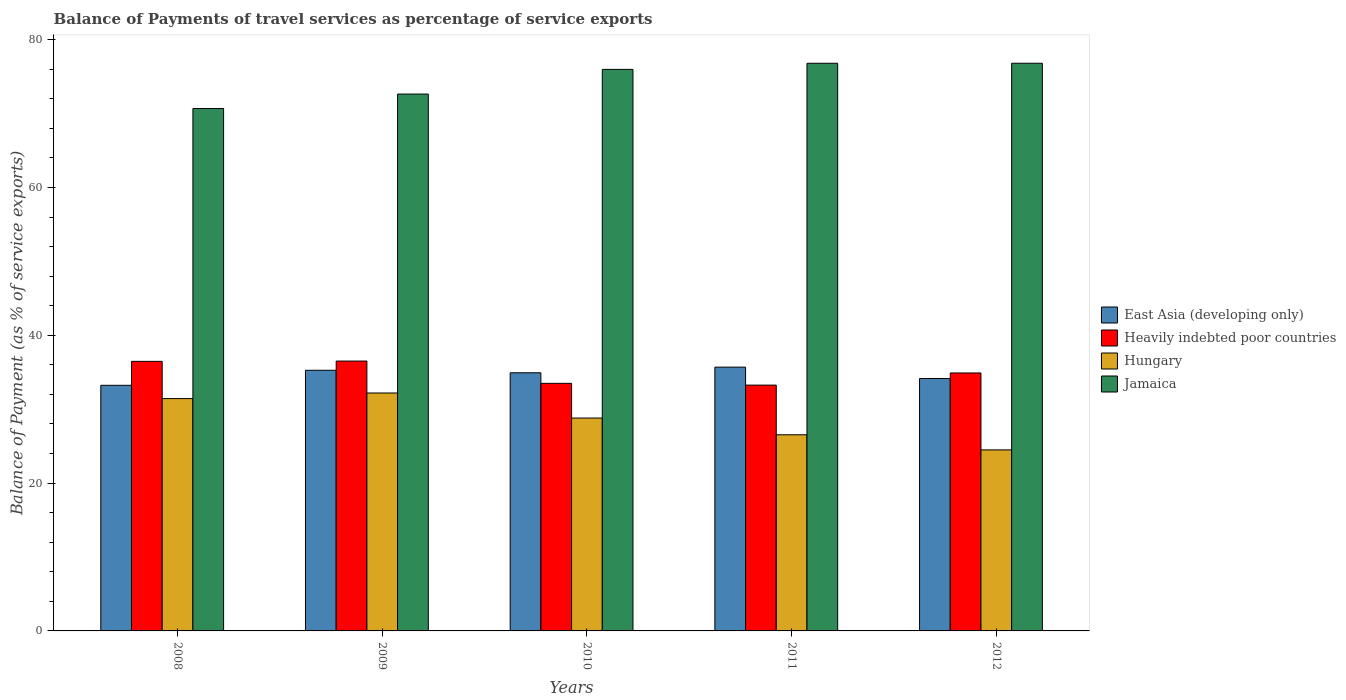How many bars are there on the 5th tick from the left?
Provide a succinct answer. 4. How many bars are there on the 3rd tick from the right?
Offer a very short reply. 4. In how many cases, is the number of bars for a given year not equal to the number of legend labels?
Make the answer very short. 0. What is the balance of payments of travel services in Heavily indebted poor countries in 2010?
Provide a succinct answer. 33.5. Across all years, what is the maximum balance of payments of travel services in East Asia (developing only)?
Provide a short and direct response. 35.69. Across all years, what is the minimum balance of payments of travel services in Hungary?
Give a very brief answer. 24.5. In which year was the balance of payments of travel services in Heavily indebted poor countries maximum?
Keep it short and to the point. 2009. What is the total balance of payments of travel services in Hungary in the graph?
Your response must be concise. 143.47. What is the difference between the balance of payments of travel services in Heavily indebted poor countries in 2009 and that in 2010?
Your answer should be very brief. 3.01. What is the difference between the balance of payments of travel services in East Asia (developing only) in 2009 and the balance of payments of travel services in Jamaica in 2012?
Make the answer very short. -41.54. What is the average balance of payments of travel services in Hungary per year?
Your answer should be very brief. 28.69. In the year 2011, what is the difference between the balance of payments of travel services in Hungary and balance of payments of travel services in Heavily indebted poor countries?
Provide a short and direct response. -6.72. In how many years, is the balance of payments of travel services in Heavily indebted poor countries greater than 44 %?
Provide a short and direct response. 0. What is the ratio of the balance of payments of travel services in Jamaica in 2009 to that in 2011?
Make the answer very short. 0.95. Is the balance of payments of travel services in Heavily indebted poor countries in 2008 less than that in 2011?
Your answer should be very brief. No. Is the difference between the balance of payments of travel services in Hungary in 2011 and 2012 greater than the difference between the balance of payments of travel services in Heavily indebted poor countries in 2011 and 2012?
Make the answer very short. Yes. What is the difference between the highest and the second highest balance of payments of travel services in East Asia (developing only)?
Your answer should be very brief. 0.43. What is the difference between the highest and the lowest balance of payments of travel services in Hungary?
Offer a very short reply. 7.7. In how many years, is the balance of payments of travel services in Hungary greater than the average balance of payments of travel services in Hungary taken over all years?
Keep it short and to the point. 3. Is the sum of the balance of payments of travel services in Heavily indebted poor countries in 2008 and 2012 greater than the maximum balance of payments of travel services in Jamaica across all years?
Make the answer very short. No. What does the 1st bar from the left in 2008 represents?
Your response must be concise. East Asia (developing only). What does the 3rd bar from the right in 2011 represents?
Offer a very short reply. Heavily indebted poor countries. How many years are there in the graph?
Ensure brevity in your answer.  5. Are the values on the major ticks of Y-axis written in scientific E-notation?
Your answer should be very brief. No. Does the graph contain grids?
Provide a succinct answer. No. How are the legend labels stacked?
Ensure brevity in your answer.  Vertical. What is the title of the graph?
Give a very brief answer. Balance of Payments of travel services as percentage of service exports. Does "Solomon Islands" appear as one of the legend labels in the graph?
Your answer should be very brief. No. What is the label or title of the Y-axis?
Provide a short and direct response. Balance of Payment (as % of service exports). What is the Balance of Payment (as % of service exports) of East Asia (developing only) in 2008?
Give a very brief answer. 33.23. What is the Balance of Payment (as % of service exports) in Heavily indebted poor countries in 2008?
Make the answer very short. 36.48. What is the Balance of Payment (as % of service exports) in Hungary in 2008?
Make the answer very short. 31.44. What is the Balance of Payment (as % of service exports) in Jamaica in 2008?
Provide a succinct answer. 70.69. What is the Balance of Payment (as % of service exports) in East Asia (developing only) in 2009?
Provide a succinct answer. 35.27. What is the Balance of Payment (as % of service exports) of Heavily indebted poor countries in 2009?
Your answer should be very brief. 36.51. What is the Balance of Payment (as % of service exports) in Hungary in 2009?
Keep it short and to the point. 32.2. What is the Balance of Payment (as % of service exports) in Jamaica in 2009?
Keep it short and to the point. 72.64. What is the Balance of Payment (as % of service exports) of East Asia (developing only) in 2010?
Give a very brief answer. 34.93. What is the Balance of Payment (as % of service exports) of Heavily indebted poor countries in 2010?
Your answer should be very brief. 33.5. What is the Balance of Payment (as % of service exports) of Hungary in 2010?
Make the answer very short. 28.8. What is the Balance of Payment (as % of service exports) of Jamaica in 2010?
Offer a very short reply. 75.98. What is the Balance of Payment (as % of service exports) of East Asia (developing only) in 2011?
Offer a terse response. 35.69. What is the Balance of Payment (as % of service exports) of Heavily indebted poor countries in 2011?
Keep it short and to the point. 33.26. What is the Balance of Payment (as % of service exports) in Hungary in 2011?
Provide a succinct answer. 26.54. What is the Balance of Payment (as % of service exports) in Jamaica in 2011?
Keep it short and to the point. 76.81. What is the Balance of Payment (as % of service exports) of East Asia (developing only) in 2012?
Provide a succinct answer. 34.16. What is the Balance of Payment (as % of service exports) in Heavily indebted poor countries in 2012?
Your answer should be very brief. 34.91. What is the Balance of Payment (as % of service exports) of Hungary in 2012?
Give a very brief answer. 24.5. What is the Balance of Payment (as % of service exports) of Jamaica in 2012?
Offer a terse response. 76.81. Across all years, what is the maximum Balance of Payment (as % of service exports) in East Asia (developing only)?
Your response must be concise. 35.69. Across all years, what is the maximum Balance of Payment (as % of service exports) of Heavily indebted poor countries?
Your answer should be very brief. 36.51. Across all years, what is the maximum Balance of Payment (as % of service exports) in Hungary?
Your answer should be very brief. 32.2. Across all years, what is the maximum Balance of Payment (as % of service exports) in Jamaica?
Offer a very short reply. 76.81. Across all years, what is the minimum Balance of Payment (as % of service exports) of East Asia (developing only)?
Keep it short and to the point. 33.23. Across all years, what is the minimum Balance of Payment (as % of service exports) of Heavily indebted poor countries?
Your answer should be very brief. 33.26. Across all years, what is the minimum Balance of Payment (as % of service exports) in Hungary?
Your answer should be compact. 24.5. Across all years, what is the minimum Balance of Payment (as % of service exports) in Jamaica?
Ensure brevity in your answer.  70.69. What is the total Balance of Payment (as % of service exports) in East Asia (developing only) in the graph?
Provide a short and direct response. 173.28. What is the total Balance of Payment (as % of service exports) of Heavily indebted poor countries in the graph?
Keep it short and to the point. 174.65. What is the total Balance of Payment (as % of service exports) in Hungary in the graph?
Ensure brevity in your answer.  143.47. What is the total Balance of Payment (as % of service exports) of Jamaica in the graph?
Offer a terse response. 372.93. What is the difference between the Balance of Payment (as % of service exports) of East Asia (developing only) in 2008 and that in 2009?
Your response must be concise. -2.03. What is the difference between the Balance of Payment (as % of service exports) of Heavily indebted poor countries in 2008 and that in 2009?
Your answer should be very brief. -0.04. What is the difference between the Balance of Payment (as % of service exports) of Hungary in 2008 and that in 2009?
Your response must be concise. -0.76. What is the difference between the Balance of Payment (as % of service exports) of Jamaica in 2008 and that in 2009?
Offer a terse response. -1.96. What is the difference between the Balance of Payment (as % of service exports) in East Asia (developing only) in 2008 and that in 2010?
Ensure brevity in your answer.  -1.7. What is the difference between the Balance of Payment (as % of service exports) of Heavily indebted poor countries in 2008 and that in 2010?
Provide a succinct answer. 2.98. What is the difference between the Balance of Payment (as % of service exports) of Hungary in 2008 and that in 2010?
Your answer should be compact. 2.63. What is the difference between the Balance of Payment (as % of service exports) in Jamaica in 2008 and that in 2010?
Provide a succinct answer. -5.29. What is the difference between the Balance of Payment (as % of service exports) in East Asia (developing only) in 2008 and that in 2011?
Your response must be concise. -2.46. What is the difference between the Balance of Payment (as % of service exports) of Heavily indebted poor countries in 2008 and that in 2011?
Offer a very short reply. 3.22. What is the difference between the Balance of Payment (as % of service exports) of Hungary in 2008 and that in 2011?
Your response must be concise. 4.9. What is the difference between the Balance of Payment (as % of service exports) of Jamaica in 2008 and that in 2011?
Offer a very short reply. -6.12. What is the difference between the Balance of Payment (as % of service exports) in East Asia (developing only) in 2008 and that in 2012?
Offer a terse response. -0.92. What is the difference between the Balance of Payment (as % of service exports) in Heavily indebted poor countries in 2008 and that in 2012?
Your response must be concise. 1.57. What is the difference between the Balance of Payment (as % of service exports) of Hungary in 2008 and that in 2012?
Provide a succinct answer. 6.94. What is the difference between the Balance of Payment (as % of service exports) in Jamaica in 2008 and that in 2012?
Offer a terse response. -6.12. What is the difference between the Balance of Payment (as % of service exports) of East Asia (developing only) in 2009 and that in 2010?
Offer a terse response. 0.34. What is the difference between the Balance of Payment (as % of service exports) of Heavily indebted poor countries in 2009 and that in 2010?
Provide a succinct answer. 3.01. What is the difference between the Balance of Payment (as % of service exports) of Hungary in 2009 and that in 2010?
Offer a terse response. 3.39. What is the difference between the Balance of Payment (as % of service exports) of Jamaica in 2009 and that in 2010?
Offer a terse response. -3.34. What is the difference between the Balance of Payment (as % of service exports) in East Asia (developing only) in 2009 and that in 2011?
Give a very brief answer. -0.43. What is the difference between the Balance of Payment (as % of service exports) of Heavily indebted poor countries in 2009 and that in 2011?
Keep it short and to the point. 3.26. What is the difference between the Balance of Payment (as % of service exports) in Hungary in 2009 and that in 2011?
Offer a very short reply. 5.65. What is the difference between the Balance of Payment (as % of service exports) of Jamaica in 2009 and that in 2011?
Your answer should be compact. -4.16. What is the difference between the Balance of Payment (as % of service exports) in East Asia (developing only) in 2009 and that in 2012?
Your response must be concise. 1.11. What is the difference between the Balance of Payment (as % of service exports) of Heavily indebted poor countries in 2009 and that in 2012?
Keep it short and to the point. 1.61. What is the difference between the Balance of Payment (as % of service exports) in Jamaica in 2009 and that in 2012?
Your response must be concise. -4.17. What is the difference between the Balance of Payment (as % of service exports) of East Asia (developing only) in 2010 and that in 2011?
Your response must be concise. -0.76. What is the difference between the Balance of Payment (as % of service exports) in Heavily indebted poor countries in 2010 and that in 2011?
Ensure brevity in your answer.  0.24. What is the difference between the Balance of Payment (as % of service exports) in Hungary in 2010 and that in 2011?
Provide a short and direct response. 2.26. What is the difference between the Balance of Payment (as % of service exports) in Jamaica in 2010 and that in 2011?
Ensure brevity in your answer.  -0.83. What is the difference between the Balance of Payment (as % of service exports) in East Asia (developing only) in 2010 and that in 2012?
Offer a terse response. 0.77. What is the difference between the Balance of Payment (as % of service exports) in Heavily indebted poor countries in 2010 and that in 2012?
Make the answer very short. -1.41. What is the difference between the Balance of Payment (as % of service exports) of Hungary in 2010 and that in 2012?
Offer a very short reply. 4.31. What is the difference between the Balance of Payment (as % of service exports) of Jamaica in 2010 and that in 2012?
Your answer should be compact. -0.83. What is the difference between the Balance of Payment (as % of service exports) of East Asia (developing only) in 2011 and that in 2012?
Your answer should be very brief. 1.54. What is the difference between the Balance of Payment (as % of service exports) in Heavily indebted poor countries in 2011 and that in 2012?
Keep it short and to the point. -1.65. What is the difference between the Balance of Payment (as % of service exports) of Hungary in 2011 and that in 2012?
Your response must be concise. 2.05. What is the difference between the Balance of Payment (as % of service exports) in Jamaica in 2011 and that in 2012?
Provide a succinct answer. -0. What is the difference between the Balance of Payment (as % of service exports) in East Asia (developing only) in 2008 and the Balance of Payment (as % of service exports) in Heavily indebted poor countries in 2009?
Your response must be concise. -3.28. What is the difference between the Balance of Payment (as % of service exports) of East Asia (developing only) in 2008 and the Balance of Payment (as % of service exports) of Hungary in 2009?
Your answer should be very brief. 1.04. What is the difference between the Balance of Payment (as % of service exports) of East Asia (developing only) in 2008 and the Balance of Payment (as % of service exports) of Jamaica in 2009?
Make the answer very short. -39.41. What is the difference between the Balance of Payment (as % of service exports) in Heavily indebted poor countries in 2008 and the Balance of Payment (as % of service exports) in Hungary in 2009?
Give a very brief answer. 4.28. What is the difference between the Balance of Payment (as % of service exports) of Heavily indebted poor countries in 2008 and the Balance of Payment (as % of service exports) of Jamaica in 2009?
Offer a terse response. -36.17. What is the difference between the Balance of Payment (as % of service exports) in Hungary in 2008 and the Balance of Payment (as % of service exports) in Jamaica in 2009?
Give a very brief answer. -41.21. What is the difference between the Balance of Payment (as % of service exports) in East Asia (developing only) in 2008 and the Balance of Payment (as % of service exports) in Heavily indebted poor countries in 2010?
Provide a succinct answer. -0.27. What is the difference between the Balance of Payment (as % of service exports) in East Asia (developing only) in 2008 and the Balance of Payment (as % of service exports) in Hungary in 2010?
Make the answer very short. 4.43. What is the difference between the Balance of Payment (as % of service exports) in East Asia (developing only) in 2008 and the Balance of Payment (as % of service exports) in Jamaica in 2010?
Give a very brief answer. -42.74. What is the difference between the Balance of Payment (as % of service exports) in Heavily indebted poor countries in 2008 and the Balance of Payment (as % of service exports) in Hungary in 2010?
Give a very brief answer. 7.67. What is the difference between the Balance of Payment (as % of service exports) in Heavily indebted poor countries in 2008 and the Balance of Payment (as % of service exports) in Jamaica in 2010?
Provide a short and direct response. -39.5. What is the difference between the Balance of Payment (as % of service exports) of Hungary in 2008 and the Balance of Payment (as % of service exports) of Jamaica in 2010?
Give a very brief answer. -44.54. What is the difference between the Balance of Payment (as % of service exports) of East Asia (developing only) in 2008 and the Balance of Payment (as % of service exports) of Heavily indebted poor countries in 2011?
Make the answer very short. -0.03. What is the difference between the Balance of Payment (as % of service exports) of East Asia (developing only) in 2008 and the Balance of Payment (as % of service exports) of Hungary in 2011?
Your answer should be compact. 6.69. What is the difference between the Balance of Payment (as % of service exports) in East Asia (developing only) in 2008 and the Balance of Payment (as % of service exports) in Jamaica in 2011?
Your answer should be compact. -43.57. What is the difference between the Balance of Payment (as % of service exports) of Heavily indebted poor countries in 2008 and the Balance of Payment (as % of service exports) of Hungary in 2011?
Make the answer very short. 9.94. What is the difference between the Balance of Payment (as % of service exports) of Heavily indebted poor countries in 2008 and the Balance of Payment (as % of service exports) of Jamaica in 2011?
Offer a terse response. -40.33. What is the difference between the Balance of Payment (as % of service exports) in Hungary in 2008 and the Balance of Payment (as % of service exports) in Jamaica in 2011?
Your answer should be compact. -45.37. What is the difference between the Balance of Payment (as % of service exports) of East Asia (developing only) in 2008 and the Balance of Payment (as % of service exports) of Heavily indebted poor countries in 2012?
Give a very brief answer. -1.67. What is the difference between the Balance of Payment (as % of service exports) in East Asia (developing only) in 2008 and the Balance of Payment (as % of service exports) in Hungary in 2012?
Your answer should be compact. 8.74. What is the difference between the Balance of Payment (as % of service exports) in East Asia (developing only) in 2008 and the Balance of Payment (as % of service exports) in Jamaica in 2012?
Your answer should be very brief. -43.58. What is the difference between the Balance of Payment (as % of service exports) in Heavily indebted poor countries in 2008 and the Balance of Payment (as % of service exports) in Hungary in 2012?
Your answer should be very brief. 11.98. What is the difference between the Balance of Payment (as % of service exports) of Heavily indebted poor countries in 2008 and the Balance of Payment (as % of service exports) of Jamaica in 2012?
Make the answer very short. -40.34. What is the difference between the Balance of Payment (as % of service exports) in Hungary in 2008 and the Balance of Payment (as % of service exports) in Jamaica in 2012?
Your answer should be compact. -45.37. What is the difference between the Balance of Payment (as % of service exports) of East Asia (developing only) in 2009 and the Balance of Payment (as % of service exports) of Heavily indebted poor countries in 2010?
Your answer should be compact. 1.77. What is the difference between the Balance of Payment (as % of service exports) of East Asia (developing only) in 2009 and the Balance of Payment (as % of service exports) of Hungary in 2010?
Your answer should be compact. 6.46. What is the difference between the Balance of Payment (as % of service exports) in East Asia (developing only) in 2009 and the Balance of Payment (as % of service exports) in Jamaica in 2010?
Give a very brief answer. -40.71. What is the difference between the Balance of Payment (as % of service exports) of Heavily indebted poor countries in 2009 and the Balance of Payment (as % of service exports) of Hungary in 2010?
Offer a very short reply. 7.71. What is the difference between the Balance of Payment (as % of service exports) of Heavily indebted poor countries in 2009 and the Balance of Payment (as % of service exports) of Jamaica in 2010?
Provide a succinct answer. -39.46. What is the difference between the Balance of Payment (as % of service exports) of Hungary in 2009 and the Balance of Payment (as % of service exports) of Jamaica in 2010?
Offer a terse response. -43.78. What is the difference between the Balance of Payment (as % of service exports) in East Asia (developing only) in 2009 and the Balance of Payment (as % of service exports) in Heavily indebted poor countries in 2011?
Provide a succinct answer. 2.01. What is the difference between the Balance of Payment (as % of service exports) of East Asia (developing only) in 2009 and the Balance of Payment (as % of service exports) of Hungary in 2011?
Your response must be concise. 8.73. What is the difference between the Balance of Payment (as % of service exports) of East Asia (developing only) in 2009 and the Balance of Payment (as % of service exports) of Jamaica in 2011?
Give a very brief answer. -41.54. What is the difference between the Balance of Payment (as % of service exports) in Heavily indebted poor countries in 2009 and the Balance of Payment (as % of service exports) in Hungary in 2011?
Keep it short and to the point. 9.97. What is the difference between the Balance of Payment (as % of service exports) of Heavily indebted poor countries in 2009 and the Balance of Payment (as % of service exports) of Jamaica in 2011?
Make the answer very short. -40.29. What is the difference between the Balance of Payment (as % of service exports) of Hungary in 2009 and the Balance of Payment (as % of service exports) of Jamaica in 2011?
Ensure brevity in your answer.  -44.61. What is the difference between the Balance of Payment (as % of service exports) of East Asia (developing only) in 2009 and the Balance of Payment (as % of service exports) of Heavily indebted poor countries in 2012?
Your answer should be compact. 0.36. What is the difference between the Balance of Payment (as % of service exports) in East Asia (developing only) in 2009 and the Balance of Payment (as % of service exports) in Hungary in 2012?
Your answer should be very brief. 10.77. What is the difference between the Balance of Payment (as % of service exports) of East Asia (developing only) in 2009 and the Balance of Payment (as % of service exports) of Jamaica in 2012?
Ensure brevity in your answer.  -41.54. What is the difference between the Balance of Payment (as % of service exports) in Heavily indebted poor countries in 2009 and the Balance of Payment (as % of service exports) in Hungary in 2012?
Your answer should be very brief. 12.02. What is the difference between the Balance of Payment (as % of service exports) of Heavily indebted poor countries in 2009 and the Balance of Payment (as % of service exports) of Jamaica in 2012?
Your response must be concise. -40.3. What is the difference between the Balance of Payment (as % of service exports) in Hungary in 2009 and the Balance of Payment (as % of service exports) in Jamaica in 2012?
Your answer should be compact. -44.62. What is the difference between the Balance of Payment (as % of service exports) in East Asia (developing only) in 2010 and the Balance of Payment (as % of service exports) in Heavily indebted poor countries in 2011?
Provide a short and direct response. 1.67. What is the difference between the Balance of Payment (as % of service exports) of East Asia (developing only) in 2010 and the Balance of Payment (as % of service exports) of Hungary in 2011?
Make the answer very short. 8.39. What is the difference between the Balance of Payment (as % of service exports) in East Asia (developing only) in 2010 and the Balance of Payment (as % of service exports) in Jamaica in 2011?
Offer a very short reply. -41.88. What is the difference between the Balance of Payment (as % of service exports) of Heavily indebted poor countries in 2010 and the Balance of Payment (as % of service exports) of Hungary in 2011?
Offer a terse response. 6.96. What is the difference between the Balance of Payment (as % of service exports) in Heavily indebted poor countries in 2010 and the Balance of Payment (as % of service exports) in Jamaica in 2011?
Provide a succinct answer. -43.31. What is the difference between the Balance of Payment (as % of service exports) in Hungary in 2010 and the Balance of Payment (as % of service exports) in Jamaica in 2011?
Your answer should be compact. -48. What is the difference between the Balance of Payment (as % of service exports) of East Asia (developing only) in 2010 and the Balance of Payment (as % of service exports) of Heavily indebted poor countries in 2012?
Your answer should be very brief. 0.03. What is the difference between the Balance of Payment (as % of service exports) of East Asia (developing only) in 2010 and the Balance of Payment (as % of service exports) of Hungary in 2012?
Offer a terse response. 10.44. What is the difference between the Balance of Payment (as % of service exports) in East Asia (developing only) in 2010 and the Balance of Payment (as % of service exports) in Jamaica in 2012?
Provide a succinct answer. -41.88. What is the difference between the Balance of Payment (as % of service exports) of Heavily indebted poor countries in 2010 and the Balance of Payment (as % of service exports) of Hungary in 2012?
Make the answer very short. 9. What is the difference between the Balance of Payment (as % of service exports) in Heavily indebted poor countries in 2010 and the Balance of Payment (as % of service exports) in Jamaica in 2012?
Keep it short and to the point. -43.31. What is the difference between the Balance of Payment (as % of service exports) in Hungary in 2010 and the Balance of Payment (as % of service exports) in Jamaica in 2012?
Give a very brief answer. -48.01. What is the difference between the Balance of Payment (as % of service exports) of East Asia (developing only) in 2011 and the Balance of Payment (as % of service exports) of Heavily indebted poor countries in 2012?
Provide a short and direct response. 0.79. What is the difference between the Balance of Payment (as % of service exports) in East Asia (developing only) in 2011 and the Balance of Payment (as % of service exports) in Hungary in 2012?
Provide a succinct answer. 11.2. What is the difference between the Balance of Payment (as % of service exports) of East Asia (developing only) in 2011 and the Balance of Payment (as % of service exports) of Jamaica in 2012?
Your answer should be compact. -41.12. What is the difference between the Balance of Payment (as % of service exports) of Heavily indebted poor countries in 2011 and the Balance of Payment (as % of service exports) of Hungary in 2012?
Your response must be concise. 8.76. What is the difference between the Balance of Payment (as % of service exports) of Heavily indebted poor countries in 2011 and the Balance of Payment (as % of service exports) of Jamaica in 2012?
Offer a very short reply. -43.55. What is the difference between the Balance of Payment (as % of service exports) of Hungary in 2011 and the Balance of Payment (as % of service exports) of Jamaica in 2012?
Offer a very short reply. -50.27. What is the average Balance of Payment (as % of service exports) in East Asia (developing only) per year?
Provide a short and direct response. 34.66. What is the average Balance of Payment (as % of service exports) of Heavily indebted poor countries per year?
Provide a short and direct response. 34.93. What is the average Balance of Payment (as % of service exports) of Hungary per year?
Give a very brief answer. 28.69. What is the average Balance of Payment (as % of service exports) in Jamaica per year?
Your response must be concise. 74.59. In the year 2008, what is the difference between the Balance of Payment (as % of service exports) of East Asia (developing only) and Balance of Payment (as % of service exports) of Heavily indebted poor countries?
Offer a very short reply. -3.24. In the year 2008, what is the difference between the Balance of Payment (as % of service exports) of East Asia (developing only) and Balance of Payment (as % of service exports) of Hungary?
Your answer should be compact. 1.8. In the year 2008, what is the difference between the Balance of Payment (as % of service exports) in East Asia (developing only) and Balance of Payment (as % of service exports) in Jamaica?
Ensure brevity in your answer.  -37.45. In the year 2008, what is the difference between the Balance of Payment (as % of service exports) of Heavily indebted poor countries and Balance of Payment (as % of service exports) of Hungary?
Your answer should be very brief. 5.04. In the year 2008, what is the difference between the Balance of Payment (as % of service exports) in Heavily indebted poor countries and Balance of Payment (as % of service exports) in Jamaica?
Provide a short and direct response. -34.21. In the year 2008, what is the difference between the Balance of Payment (as % of service exports) of Hungary and Balance of Payment (as % of service exports) of Jamaica?
Offer a terse response. -39.25. In the year 2009, what is the difference between the Balance of Payment (as % of service exports) of East Asia (developing only) and Balance of Payment (as % of service exports) of Heavily indebted poor countries?
Make the answer very short. -1.25. In the year 2009, what is the difference between the Balance of Payment (as % of service exports) in East Asia (developing only) and Balance of Payment (as % of service exports) in Hungary?
Offer a terse response. 3.07. In the year 2009, what is the difference between the Balance of Payment (as % of service exports) in East Asia (developing only) and Balance of Payment (as % of service exports) in Jamaica?
Provide a short and direct response. -37.38. In the year 2009, what is the difference between the Balance of Payment (as % of service exports) in Heavily indebted poor countries and Balance of Payment (as % of service exports) in Hungary?
Ensure brevity in your answer.  4.32. In the year 2009, what is the difference between the Balance of Payment (as % of service exports) in Heavily indebted poor countries and Balance of Payment (as % of service exports) in Jamaica?
Your answer should be very brief. -36.13. In the year 2009, what is the difference between the Balance of Payment (as % of service exports) in Hungary and Balance of Payment (as % of service exports) in Jamaica?
Offer a very short reply. -40.45. In the year 2010, what is the difference between the Balance of Payment (as % of service exports) in East Asia (developing only) and Balance of Payment (as % of service exports) in Heavily indebted poor countries?
Make the answer very short. 1.43. In the year 2010, what is the difference between the Balance of Payment (as % of service exports) of East Asia (developing only) and Balance of Payment (as % of service exports) of Hungary?
Offer a very short reply. 6.13. In the year 2010, what is the difference between the Balance of Payment (as % of service exports) in East Asia (developing only) and Balance of Payment (as % of service exports) in Jamaica?
Your response must be concise. -41.05. In the year 2010, what is the difference between the Balance of Payment (as % of service exports) in Heavily indebted poor countries and Balance of Payment (as % of service exports) in Hungary?
Make the answer very short. 4.7. In the year 2010, what is the difference between the Balance of Payment (as % of service exports) of Heavily indebted poor countries and Balance of Payment (as % of service exports) of Jamaica?
Make the answer very short. -42.48. In the year 2010, what is the difference between the Balance of Payment (as % of service exports) in Hungary and Balance of Payment (as % of service exports) in Jamaica?
Keep it short and to the point. -47.17. In the year 2011, what is the difference between the Balance of Payment (as % of service exports) of East Asia (developing only) and Balance of Payment (as % of service exports) of Heavily indebted poor countries?
Give a very brief answer. 2.43. In the year 2011, what is the difference between the Balance of Payment (as % of service exports) of East Asia (developing only) and Balance of Payment (as % of service exports) of Hungary?
Make the answer very short. 9.15. In the year 2011, what is the difference between the Balance of Payment (as % of service exports) of East Asia (developing only) and Balance of Payment (as % of service exports) of Jamaica?
Provide a short and direct response. -41.11. In the year 2011, what is the difference between the Balance of Payment (as % of service exports) in Heavily indebted poor countries and Balance of Payment (as % of service exports) in Hungary?
Offer a very short reply. 6.72. In the year 2011, what is the difference between the Balance of Payment (as % of service exports) of Heavily indebted poor countries and Balance of Payment (as % of service exports) of Jamaica?
Give a very brief answer. -43.55. In the year 2011, what is the difference between the Balance of Payment (as % of service exports) of Hungary and Balance of Payment (as % of service exports) of Jamaica?
Give a very brief answer. -50.27. In the year 2012, what is the difference between the Balance of Payment (as % of service exports) in East Asia (developing only) and Balance of Payment (as % of service exports) in Heavily indebted poor countries?
Offer a terse response. -0.75. In the year 2012, what is the difference between the Balance of Payment (as % of service exports) of East Asia (developing only) and Balance of Payment (as % of service exports) of Hungary?
Keep it short and to the point. 9.66. In the year 2012, what is the difference between the Balance of Payment (as % of service exports) in East Asia (developing only) and Balance of Payment (as % of service exports) in Jamaica?
Ensure brevity in your answer.  -42.65. In the year 2012, what is the difference between the Balance of Payment (as % of service exports) in Heavily indebted poor countries and Balance of Payment (as % of service exports) in Hungary?
Offer a very short reply. 10.41. In the year 2012, what is the difference between the Balance of Payment (as % of service exports) of Heavily indebted poor countries and Balance of Payment (as % of service exports) of Jamaica?
Your response must be concise. -41.91. In the year 2012, what is the difference between the Balance of Payment (as % of service exports) of Hungary and Balance of Payment (as % of service exports) of Jamaica?
Make the answer very short. -52.32. What is the ratio of the Balance of Payment (as % of service exports) in East Asia (developing only) in 2008 to that in 2009?
Keep it short and to the point. 0.94. What is the ratio of the Balance of Payment (as % of service exports) of Hungary in 2008 to that in 2009?
Your answer should be compact. 0.98. What is the ratio of the Balance of Payment (as % of service exports) of Jamaica in 2008 to that in 2009?
Your response must be concise. 0.97. What is the ratio of the Balance of Payment (as % of service exports) in East Asia (developing only) in 2008 to that in 2010?
Your answer should be compact. 0.95. What is the ratio of the Balance of Payment (as % of service exports) of Heavily indebted poor countries in 2008 to that in 2010?
Make the answer very short. 1.09. What is the ratio of the Balance of Payment (as % of service exports) of Hungary in 2008 to that in 2010?
Your response must be concise. 1.09. What is the ratio of the Balance of Payment (as % of service exports) of Jamaica in 2008 to that in 2010?
Give a very brief answer. 0.93. What is the ratio of the Balance of Payment (as % of service exports) of East Asia (developing only) in 2008 to that in 2011?
Keep it short and to the point. 0.93. What is the ratio of the Balance of Payment (as % of service exports) of Heavily indebted poor countries in 2008 to that in 2011?
Your response must be concise. 1.1. What is the ratio of the Balance of Payment (as % of service exports) of Hungary in 2008 to that in 2011?
Keep it short and to the point. 1.18. What is the ratio of the Balance of Payment (as % of service exports) of Jamaica in 2008 to that in 2011?
Keep it short and to the point. 0.92. What is the ratio of the Balance of Payment (as % of service exports) in Heavily indebted poor countries in 2008 to that in 2012?
Your response must be concise. 1.04. What is the ratio of the Balance of Payment (as % of service exports) of Hungary in 2008 to that in 2012?
Your response must be concise. 1.28. What is the ratio of the Balance of Payment (as % of service exports) in Jamaica in 2008 to that in 2012?
Provide a succinct answer. 0.92. What is the ratio of the Balance of Payment (as % of service exports) of East Asia (developing only) in 2009 to that in 2010?
Ensure brevity in your answer.  1.01. What is the ratio of the Balance of Payment (as % of service exports) of Heavily indebted poor countries in 2009 to that in 2010?
Offer a terse response. 1.09. What is the ratio of the Balance of Payment (as % of service exports) of Hungary in 2009 to that in 2010?
Offer a very short reply. 1.12. What is the ratio of the Balance of Payment (as % of service exports) of Jamaica in 2009 to that in 2010?
Provide a succinct answer. 0.96. What is the ratio of the Balance of Payment (as % of service exports) in East Asia (developing only) in 2009 to that in 2011?
Offer a terse response. 0.99. What is the ratio of the Balance of Payment (as % of service exports) of Heavily indebted poor countries in 2009 to that in 2011?
Your answer should be compact. 1.1. What is the ratio of the Balance of Payment (as % of service exports) of Hungary in 2009 to that in 2011?
Offer a terse response. 1.21. What is the ratio of the Balance of Payment (as % of service exports) in Jamaica in 2009 to that in 2011?
Make the answer very short. 0.95. What is the ratio of the Balance of Payment (as % of service exports) in East Asia (developing only) in 2009 to that in 2012?
Your answer should be very brief. 1.03. What is the ratio of the Balance of Payment (as % of service exports) of Heavily indebted poor countries in 2009 to that in 2012?
Provide a short and direct response. 1.05. What is the ratio of the Balance of Payment (as % of service exports) in Hungary in 2009 to that in 2012?
Make the answer very short. 1.31. What is the ratio of the Balance of Payment (as % of service exports) in Jamaica in 2009 to that in 2012?
Keep it short and to the point. 0.95. What is the ratio of the Balance of Payment (as % of service exports) of East Asia (developing only) in 2010 to that in 2011?
Ensure brevity in your answer.  0.98. What is the ratio of the Balance of Payment (as % of service exports) of Hungary in 2010 to that in 2011?
Keep it short and to the point. 1.09. What is the ratio of the Balance of Payment (as % of service exports) in Jamaica in 2010 to that in 2011?
Make the answer very short. 0.99. What is the ratio of the Balance of Payment (as % of service exports) in East Asia (developing only) in 2010 to that in 2012?
Your response must be concise. 1.02. What is the ratio of the Balance of Payment (as % of service exports) of Heavily indebted poor countries in 2010 to that in 2012?
Your answer should be compact. 0.96. What is the ratio of the Balance of Payment (as % of service exports) in Hungary in 2010 to that in 2012?
Your answer should be very brief. 1.18. What is the ratio of the Balance of Payment (as % of service exports) in East Asia (developing only) in 2011 to that in 2012?
Keep it short and to the point. 1.04. What is the ratio of the Balance of Payment (as % of service exports) of Heavily indebted poor countries in 2011 to that in 2012?
Your answer should be compact. 0.95. What is the ratio of the Balance of Payment (as % of service exports) of Hungary in 2011 to that in 2012?
Ensure brevity in your answer.  1.08. What is the difference between the highest and the second highest Balance of Payment (as % of service exports) in East Asia (developing only)?
Your response must be concise. 0.43. What is the difference between the highest and the second highest Balance of Payment (as % of service exports) in Heavily indebted poor countries?
Keep it short and to the point. 0.04. What is the difference between the highest and the second highest Balance of Payment (as % of service exports) in Hungary?
Offer a terse response. 0.76. What is the difference between the highest and the second highest Balance of Payment (as % of service exports) in Jamaica?
Your answer should be compact. 0. What is the difference between the highest and the lowest Balance of Payment (as % of service exports) of East Asia (developing only)?
Make the answer very short. 2.46. What is the difference between the highest and the lowest Balance of Payment (as % of service exports) in Heavily indebted poor countries?
Your answer should be compact. 3.26. What is the difference between the highest and the lowest Balance of Payment (as % of service exports) in Jamaica?
Provide a short and direct response. 6.12. 